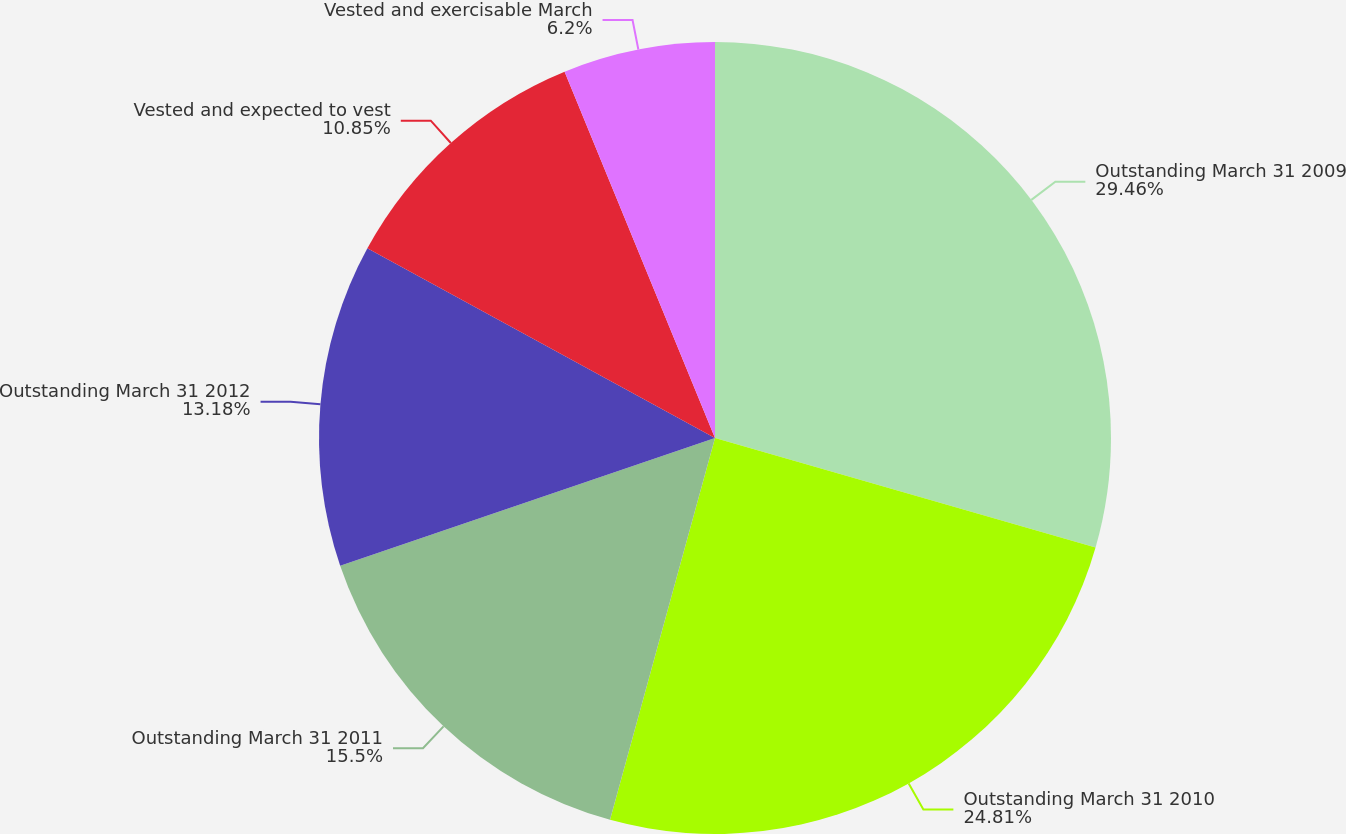<chart> <loc_0><loc_0><loc_500><loc_500><pie_chart><fcel>Outstanding March 31 2009<fcel>Outstanding March 31 2010<fcel>Outstanding March 31 2011<fcel>Outstanding March 31 2012<fcel>Vested and expected to vest<fcel>Vested and exercisable March<nl><fcel>29.46%<fcel>24.81%<fcel>15.5%<fcel>13.18%<fcel>10.85%<fcel>6.2%<nl></chart> 